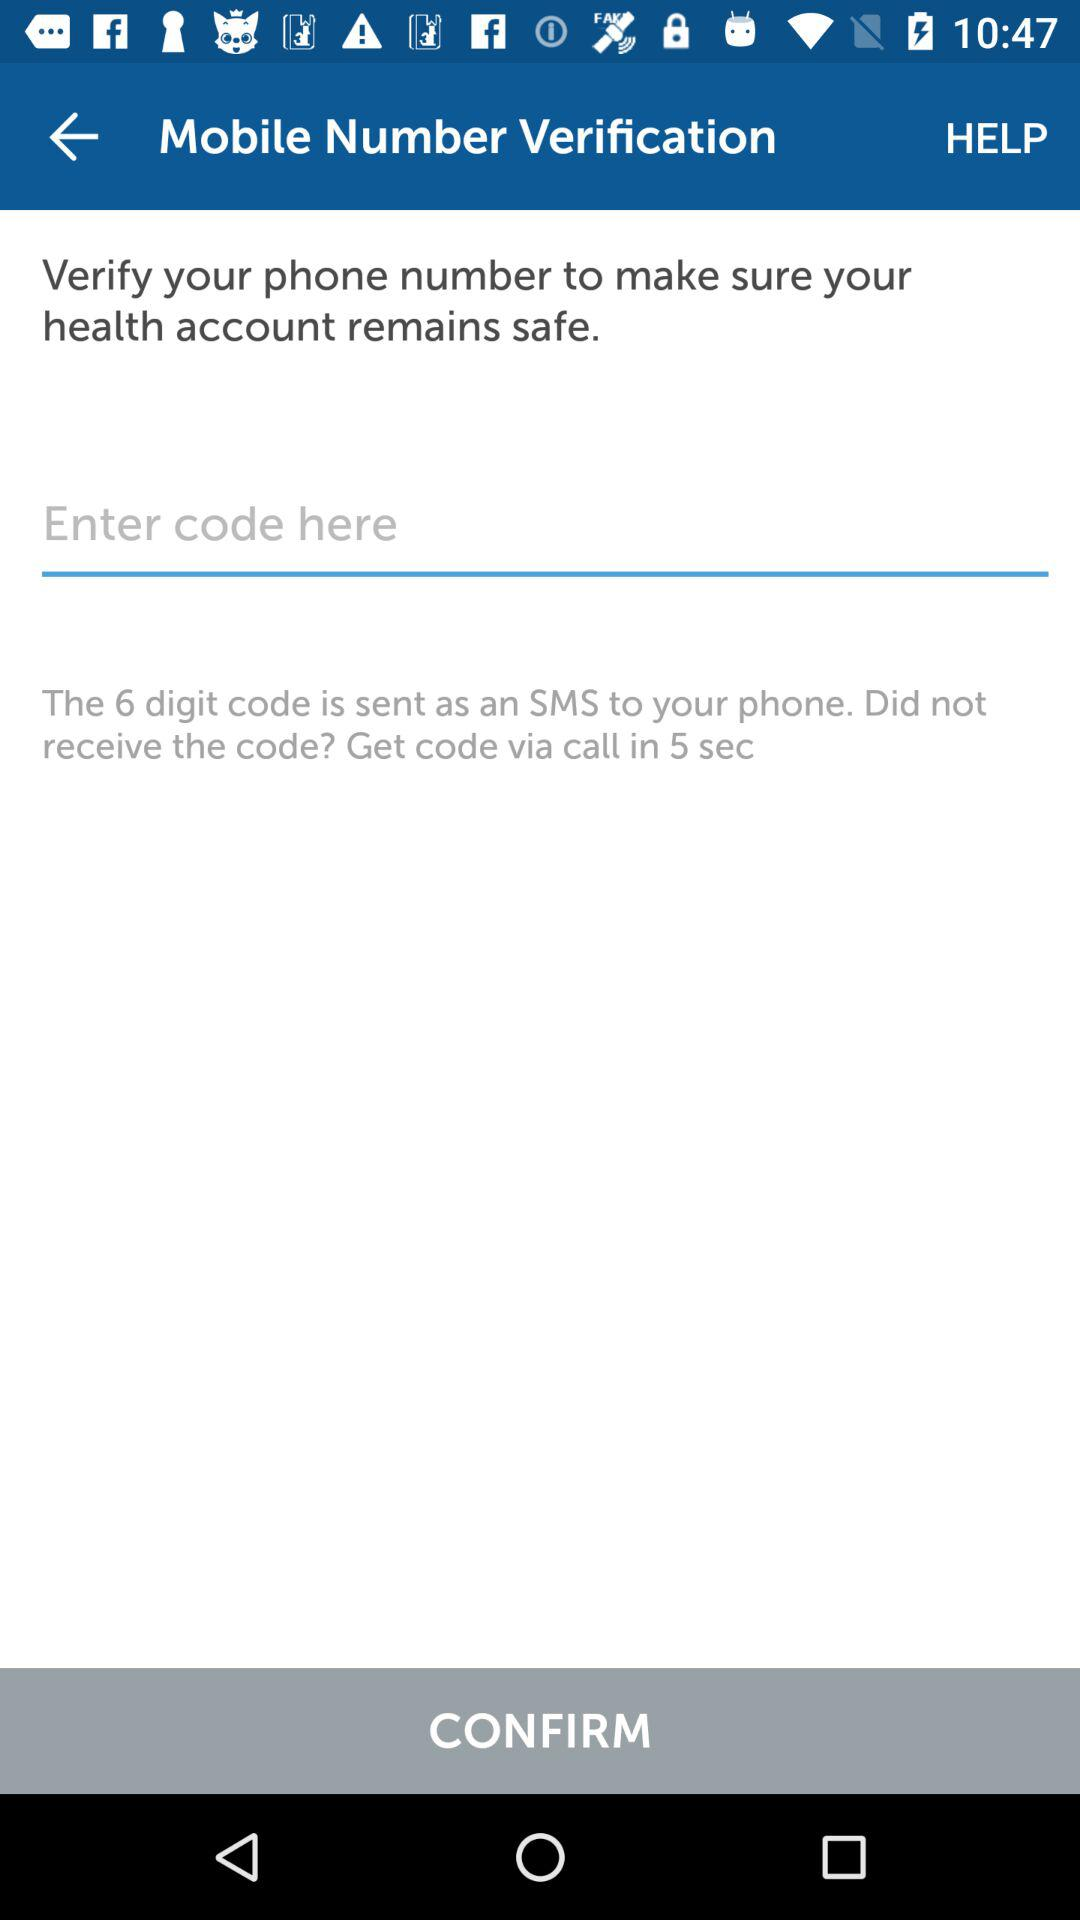How many digits are in the code?
Answer the question using a single word or phrase. 6 